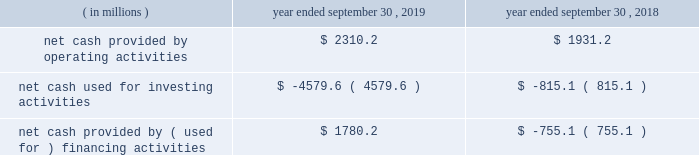Credit facilities .
As such , our foreign cash and cash equivalents are not expected to be a key source of liquidity to our domestic operations .
At september 30 , 2019 , we had approximately $ 2.9 billion of availability under our committed credit facilities , primarily under our revolving credit facility , the majority of which matures on july 1 , 2022 .
This liquidity may be used to provide for ongoing working capital needs and for other general corporate purposes , including acquisitions , dividends and stock repurchases .
Certain restrictive covenants govern our maximum availability under the credit facilities .
We test and report our compliance with these covenants as required and we were in compliance with all of these covenants at september 30 , 2019 .
At september 30 , 2019 , we had $ 129.8 million of outstanding letters of credit not drawn cash and cash equivalents were $ 151.6 million at september 30 , 2019 and $ 636.8 million at september 30 , 2018 .
We used a significant portion of the cash and cash equivalents on hand at september 30 , 2018 in connection with the closing of the kapstone acquisition .
Primarily all of the cash and cash equivalents at september 30 , 2019 were held outside of the u.s .
At september 30 , 2019 , total debt was $ 10063.4 million , $ 561.1 million of which was current .
At september 30 , 2018 , total debt was $ 6415.2 million , $ 740.7 million of which was current .
The increase in debt was primarily related to the kapstone acquisition .
Cash flow activity .
Net cash provided by operating activities during fiscal 2019 increased $ 379.0 million from fiscal 2018 primarily due to higher cash earnings and a $ 340.3 million net decrease in the use of working capital compared to the prior year .
As a result of the retrospective adoption of asu 2016-15 and asu 2016-18 ( each as hereinafter defined ) as discussed in 201cnote 1 .
Description of business and summary of significant accounting policies 201d of the notes to consolidated financial statements , net cash provided by operating activities for fiscal 2018 was reduced by $ 489.7 million and cash provided by investing activities increased $ 483.8 million , primarily for the change in classification of proceeds received for beneficial interests obtained for transferring trade receivables in securitization transactions .
Net cash used for investing activities of $ 4579.6 million in fiscal 2019 consisted primarily of $ 3374.2 million for cash paid for the purchase of businesses , net of cash acquired ( excluding the assumption of debt ) , primarily related to the kapstone acquisition , and $ 1369.1 million for capital expenditures that were partially offset by $ 119.1 million of proceeds from the sale of property , plant and equipment primarily related to the sale of our atlanta beverage facility , $ 33.2 million of proceeds from corporate owned life insurance benefits and $ 25.5 million of proceeds from property , plant and equipment insurance proceeds related to the panama city , fl mill .
Net cash used for investing activities of $ 815.1 million in fiscal 2018 consisted primarily of $ 999.9 million for capital expenditures , $ 239.9 million for cash paid for the purchase of businesses , net of cash acquired primarily related to the plymouth acquisition and the schl fcter acquisition , and $ 108.0 million for an investment in grupo gondi .
These investments were partially offset by $ 461.6 million of cash receipts on sold trade receivables as a result of the adoption of asu 2016-15 , $ 24.0 million of proceeds from the sale of certain affiliates as well as our solid waste management brokerage services business and $ 23.3 million of proceeds from the sale of property , plant and equipment .
In fiscal 2019 , net cash provided by financing activities of $ 1780.2 million consisted primarily of a net increase in debt of $ 2314.6 million , primarily related to the kapstone acquisition and partially offset by cash dividends paid to stockholders of $ 467.9 million and purchases of common stock of $ 88.6 million .
In fiscal 2018 , net cash used for financing activities of $ 755.1 million consisted primarily of cash dividends paid to stockholders of $ 440.9 million and purchases of common stock of $ 195.1 million and net repayments of debt of $ 120.1 million. .
In 2019 what was the net change in cash in millions? 
Computations: ((2310.2 + -4579.6) + 1780.2)
Answer: -489.2. 